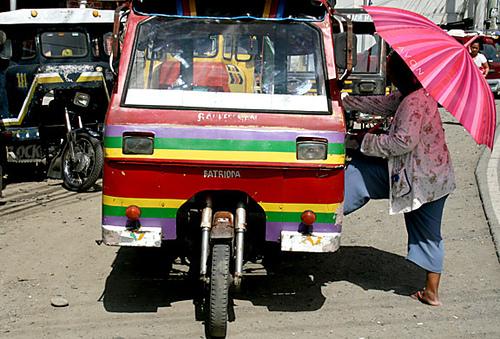How many different color stripes are on this truck?
Keep it brief. 4. How many wheels are pictured?
Quick response, please. 2. Why is the person using an umbrella?
Give a very brief answer. Shade. 